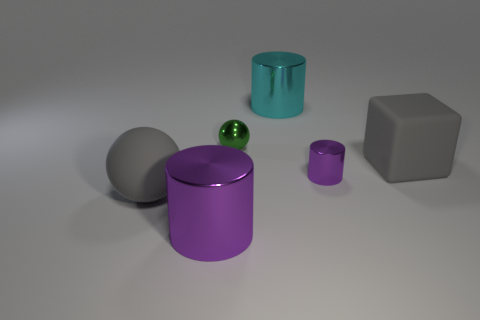There is another large metal object that is the same shape as the large purple object; what color is it?
Provide a short and direct response. Cyan. There is a gray thing that is in front of the cube; is its size the same as the gray block?
Your answer should be compact. Yes. What number of large things are either cyan metal cylinders or purple cylinders?
Offer a very short reply. 2. Is there a big rubber thing of the same color as the small metal sphere?
Your answer should be very brief. No. There is a matte object that is the same size as the gray block; what shape is it?
Your answer should be compact. Sphere. Is the color of the ball that is behind the rubber block the same as the rubber block?
Provide a succinct answer. No. What number of objects are balls behind the gray cube or purple cylinders?
Make the answer very short. 3. Is the number of big gray rubber balls that are behind the gray block greater than the number of big gray matte blocks behind the tiny purple shiny cylinder?
Your response must be concise. No. Does the cyan thing have the same material as the small purple cylinder?
Your answer should be very brief. Yes. What is the shape of the object that is on the right side of the rubber ball and left of the green shiny ball?
Ensure brevity in your answer.  Cylinder. 